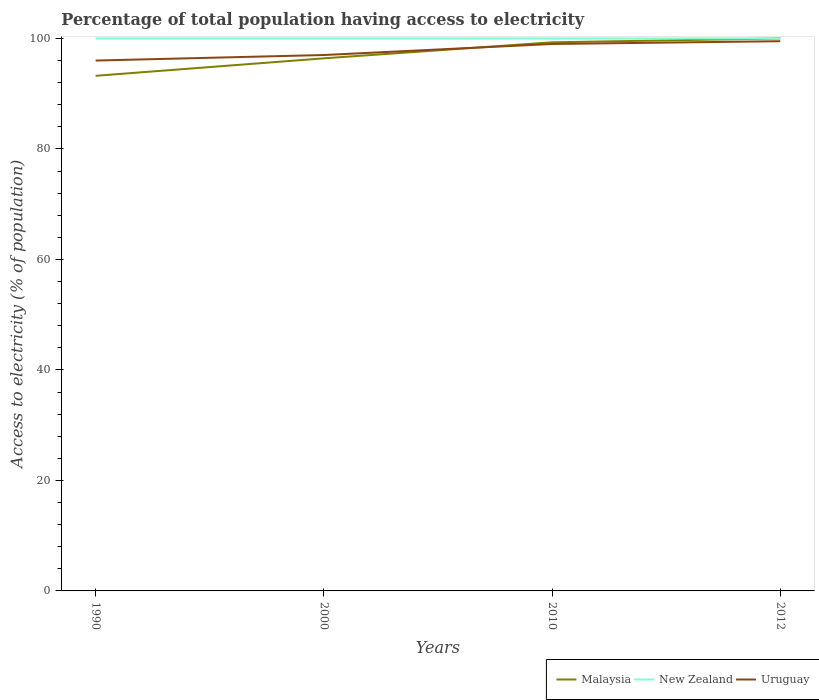How many different coloured lines are there?
Make the answer very short. 3. Is the number of lines equal to the number of legend labels?
Your answer should be very brief. Yes. Across all years, what is the maximum percentage of population that have access to electricity in Malaysia?
Provide a short and direct response. 93.24. What is the total percentage of population that have access to electricity in New Zealand in the graph?
Provide a short and direct response. 0. What is the difference between the highest and the second highest percentage of population that have access to electricity in Malaysia?
Your response must be concise. 6.76. Is the percentage of population that have access to electricity in Uruguay strictly greater than the percentage of population that have access to electricity in New Zealand over the years?
Offer a very short reply. Yes. How many lines are there?
Your answer should be compact. 3. How many years are there in the graph?
Offer a terse response. 4. Are the values on the major ticks of Y-axis written in scientific E-notation?
Provide a succinct answer. No. Does the graph contain any zero values?
Give a very brief answer. No. Where does the legend appear in the graph?
Make the answer very short. Bottom right. What is the title of the graph?
Your answer should be very brief. Percentage of total population having access to electricity. What is the label or title of the Y-axis?
Provide a short and direct response. Access to electricity (% of population). What is the Access to electricity (% of population) of Malaysia in 1990?
Make the answer very short. 93.24. What is the Access to electricity (% of population) in New Zealand in 1990?
Your answer should be very brief. 100. What is the Access to electricity (% of population) in Uruguay in 1990?
Provide a succinct answer. 96. What is the Access to electricity (% of population) in Malaysia in 2000?
Ensure brevity in your answer.  96.4. What is the Access to electricity (% of population) in New Zealand in 2000?
Give a very brief answer. 100. What is the Access to electricity (% of population) in Uruguay in 2000?
Give a very brief answer. 97. What is the Access to electricity (% of population) of Malaysia in 2010?
Your response must be concise. 99.3. What is the Access to electricity (% of population) in New Zealand in 2010?
Provide a succinct answer. 100. What is the Access to electricity (% of population) of New Zealand in 2012?
Make the answer very short. 100. What is the Access to electricity (% of population) in Uruguay in 2012?
Ensure brevity in your answer.  99.5. Across all years, what is the maximum Access to electricity (% of population) in Uruguay?
Give a very brief answer. 99.5. Across all years, what is the minimum Access to electricity (% of population) of Malaysia?
Provide a short and direct response. 93.24. Across all years, what is the minimum Access to electricity (% of population) of New Zealand?
Ensure brevity in your answer.  100. Across all years, what is the minimum Access to electricity (% of population) of Uruguay?
Your response must be concise. 96. What is the total Access to electricity (% of population) of Malaysia in the graph?
Your answer should be compact. 388.94. What is the total Access to electricity (% of population) of Uruguay in the graph?
Your answer should be very brief. 391.5. What is the difference between the Access to electricity (% of population) in Malaysia in 1990 and that in 2000?
Make the answer very short. -3.16. What is the difference between the Access to electricity (% of population) of New Zealand in 1990 and that in 2000?
Keep it short and to the point. 0. What is the difference between the Access to electricity (% of population) in Malaysia in 1990 and that in 2010?
Your response must be concise. -6.06. What is the difference between the Access to electricity (% of population) of New Zealand in 1990 and that in 2010?
Make the answer very short. 0. What is the difference between the Access to electricity (% of population) of Malaysia in 1990 and that in 2012?
Provide a succinct answer. -6.76. What is the difference between the Access to electricity (% of population) of Malaysia in 2000 and that in 2010?
Ensure brevity in your answer.  -2.9. What is the difference between the Access to electricity (% of population) of Uruguay in 2000 and that in 2012?
Give a very brief answer. -2.5. What is the difference between the Access to electricity (% of population) in New Zealand in 2010 and that in 2012?
Provide a succinct answer. 0. What is the difference between the Access to electricity (% of population) in Malaysia in 1990 and the Access to electricity (% of population) in New Zealand in 2000?
Give a very brief answer. -6.76. What is the difference between the Access to electricity (% of population) of Malaysia in 1990 and the Access to electricity (% of population) of Uruguay in 2000?
Your answer should be compact. -3.76. What is the difference between the Access to electricity (% of population) in New Zealand in 1990 and the Access to electricity (% of population) in Uruguay in 2000?
Offer a terse response. 3. What is the difference between the Access to electricity (% of population) in Malaysia in 1990 and the Access to electricity (% of population) in New Zealand in 2010?
Provide a short and direct response. -6.76. What is the difference between the Access to electricity (% of population) in Malaysia in 1990 and the Access to electricity (% of population) in Uruguay in 2010?
Your answer should be compact. -5.76. What is the difference between the Access to electricity (% of population) of New Zealand in 1990 and the Access to electricity (% of population) of Uruguay in 2010?
Make the answer very short. 1. What is the difference between the Access to electricity (% of population) in Malaysia in 1990 and the Access to electricity (% of population) in New Zealand in 2012?
Your response must be concise. -6.76. What is the difference between the Access to electricity (% of population) in Malaysia in 1990 and the Access to electricity (% of population) in Uruguay in 2012?
Offer a terse response. -6.26. What is the difference between the Access to electricity (% of population) of Malaysia in 2000 and the Access to electricity (% of population) of New Zealand in 2010?
Offer a very short reply. -3.6. What is the difference between the Access to electricity (% of population) of New Zealand in 2000 and the Access to electricity (% of population) of Uruguay in 2010?
Provide a short and direct response. 1. What is the difference between the Access to electricity (% of population) in Malaysia in 2000 and the Access to electricity (% of population) in Uruguay in 2012?
Offer a very short reply. -3.1. What is the difference between the Access to electricity (% of population) in Malaysia in 2010 and the Access to electricity (% of population) in New Zealand in 2012?
Offer a very short reply. -0.7. What is the difference between the Access to electricity (% of population) in Malaysia in 2010 and the Access to electricity (% of population) in Uruguay in 2012?
Make the answer very short. -0.2. What is the average Access to electricity (% of population) in Malaysia per year?
Your answer should be compact. 97.23. What is the average Access to electricity (% of population) of New Zealand per year?
Give a very brief answer. 100. What is the average Access to electricity (% of population) in Uruguay per year?
Give a very brief answer. 97.88. In the year 1990, what is the difference between the Access to electricity (% of population) in Malaysia and Access to electricity (% of population) in New Zealand?
Make the answer very short. -6.76. In the year 1990, what is the difference between the Access to electricity (% of population) of Malaysia and Access to electricity (% of population) of Uruguay?
Keep it short and to the point. -2.76. In the year 1990, what is the difference between the Access to electricity (% of population) of New Zealand and Access to electricity (% of population) of Uruguay?
Your response must be concise. 4. In the year 2000, what is the difference between the Access to electricity (% of population) in Malaysia and Access to electricity (% of population) in Uruguay?
Offer a terse response. -0.6. In the year 2000, what is the difference between the Access to electricity (% of population) of New Zealand and Access to electricity (% of population) of Uruguay?
Offer a terse response. 3. In the year 2010, what is the difference between the Access to electricity (% of population) of Malaysia and Access to electricity (% of population) of New Zealand?
Provide a short and direct response. -0.7. In the year 2010, what is the difference between the Access to electricity (% of population) of New Zealand and Access to electricity (% of population) of Uruguay?
Your answer should be compact. 1. In the year 2012, what is the difference between the Access to electricity (% of population) in Malaysia and Access to electricity (% of population) in Uruguay?
Give a very brief answer. 0.5. What is the ratio of the Access to electricity (% of population) in Malaysia in 1990 to that in 2000?
Make the answer very short. 0.97. What is the ratio of the Access to electricity (% of population) of New Zealand in 1990 to that in 2000?
Provide a succinct answer. 1. What is the ratio of the Access to electricity (% of population) of Malaysia in 1990 to that in 2010?
Ensure brevity in your answer.  0.94. What is the ratio of the Access to electricity (% of population) of New Zealand in 1990 to that in 2010?
Ensure brevity in your answer.  1. What is the ratio of the Access to electricity (% of population) in Uruguay in 1990 to that in 2010?
Keep it short and to the point. 0.97. What is the ratio of the Access to electricity (% of population) in Malaysia in 1990 to that in 2012?
Ensure brevity in your answer.  0.93. What is the ratio of the Access to electricity (% of population) of New Zealand in 1990 to that in 2012?
Provide a short and direct response. 1. What is the ratio of the Access to electricity (% of population) in Uruguay in 1990 to that in 2012?
Provide a succinct answer. 0.96. What is the ratio of the Access to electricity (% of population) of Malaysia in 2000 to that in 2010?
Ensure brevity in your answer.  0.97. What is the ratio of the Access to electricity (% of population) of Uruguay in 2000 to that in 2010?
Offer a terse response. 0.98. What is the ratio of the Access to electricity (% of population) of Malaysia in 2000 to that in 2012?
Make the answer very short. 0.96. What is the ratio of the Access to electricity (% of population) of New Zealand in 2000 to that in 2012?
Make the answer very short. 1. What is the ratio of the Access to electricity (% of population) in Uruguay in 2000 to that in 2012?
Your answer should be compact. 0.97. What is the ratio of the Access to electricity (% of population) of Malaysia in 2010 to that in 2012?
Offer a terse response. 0.99. What is the ratio of the Access to electricity (% of population) in New Zealand in 2010 to that in 2012?
Your answer should be very brief. 1. What is the difference between the highest and the second highest Access to electricity (% of population) of New Zealand?
Make the answer very short. 0. What is the difference between the highest and the lowest Access to electricity (% of population) of Malaysia?
Give a very brief answer. 6.76. 